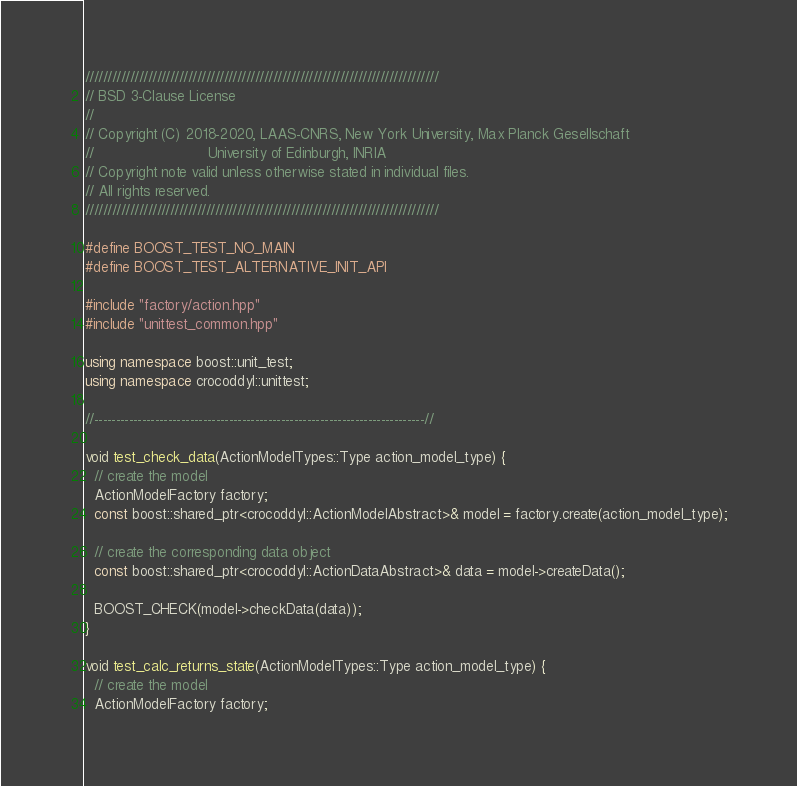Convert code to text. <code><loc_0><loc_0><loc_500><loc_500><_C++_>///////////////////////////////////////////////////////////////////////////////
// BSD 3-Clause License
//
// Copyright (C) 2018-2020, LAAS-CNRS, New York University, Max Planck Gesellschaft
//                          University of Edinburgh, INRIA
// Copyright note valid unless otherwise stated in individual files.
// All rights reserved.
///////////////////////////////////////////////////////////////////////////////

#define BOOST_TEST_NO_MAIN
#define BOOST_TEST_ALTERNATIVE_INIT_API

#include "factory/action.hpp"
#include "unittest_common.hpp"

using namespace boost::unit_test;
using namespace crocoddyl::unittest;

//----------------------------------------------------------------------------//

void test_check_data(ActionModelTypes::Type action_model_type) {
  // create the model
  ActionModelFactory factory;
  const boost::shared_ptr<crocoddyl::ActionModelAbstract>& model = factory.create(action_model_type);

  // create the corresponding data object
  const boost::shared_ptr<crocoddyl::ActionDataAbstract>& data = model->createData();

  BOOST_CHECK(model->checkData(data));
}

void test_calc_returns_state(ActionModelTypes::Type action_model_type) {
  // create the model
  ActionModelFactory factory;</code> 